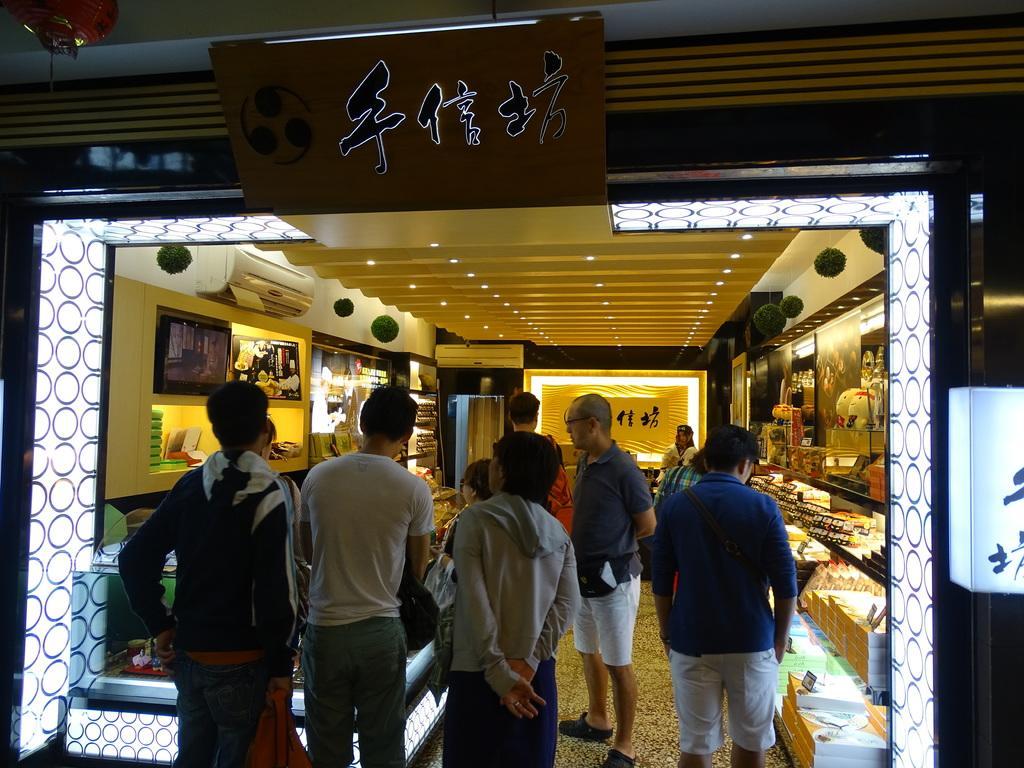How would you summarize this image in a sentence or two? In a given image i can see the inside view of the store that includes air conditioner,people,decorative objects,lights and some other objects. 